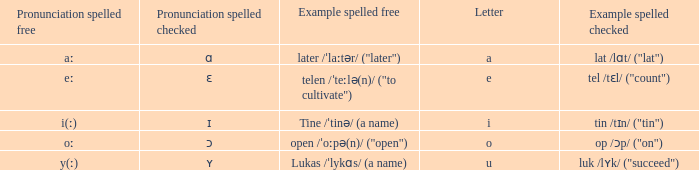What is Pronunciation Spelled Checked, when Example Spelled Checked is "tin /tɪn/ ("tin")" Ɪ. Would you mind parsing the complete table? {'header': ['Pronunciation spelled free', 'Pronunciation spelled checked', 'Example spelled free', 'Letter', 'Example spelled checked'], 'rows': [['aː', 'ɑ', 'later /ˈlaːtər/ ("later")', 'a', 'lat /lɑt/ ("lat")'], ['eː', 'ɛ', 'telen /ˈteːlə(n)/ ("to cultivate")', 'e', 'tel /tɛl/ ("count")'], ['i(ː)', 'ɪ', 'Tine /ˈtinə/ (a name)', 'i', 'tin /tɪn/ ("tin")'], ['oː', 'ɔ', 'open /ˈoːpə(n)/ ("open")', 'o', 'op /ɔp/ ("on")'], ['y(ː)', 'ʏ', 'Lukas /ˈlykɑs/ (a name)', 'u', 'luk /lʏk/ ("succeed")']]} 